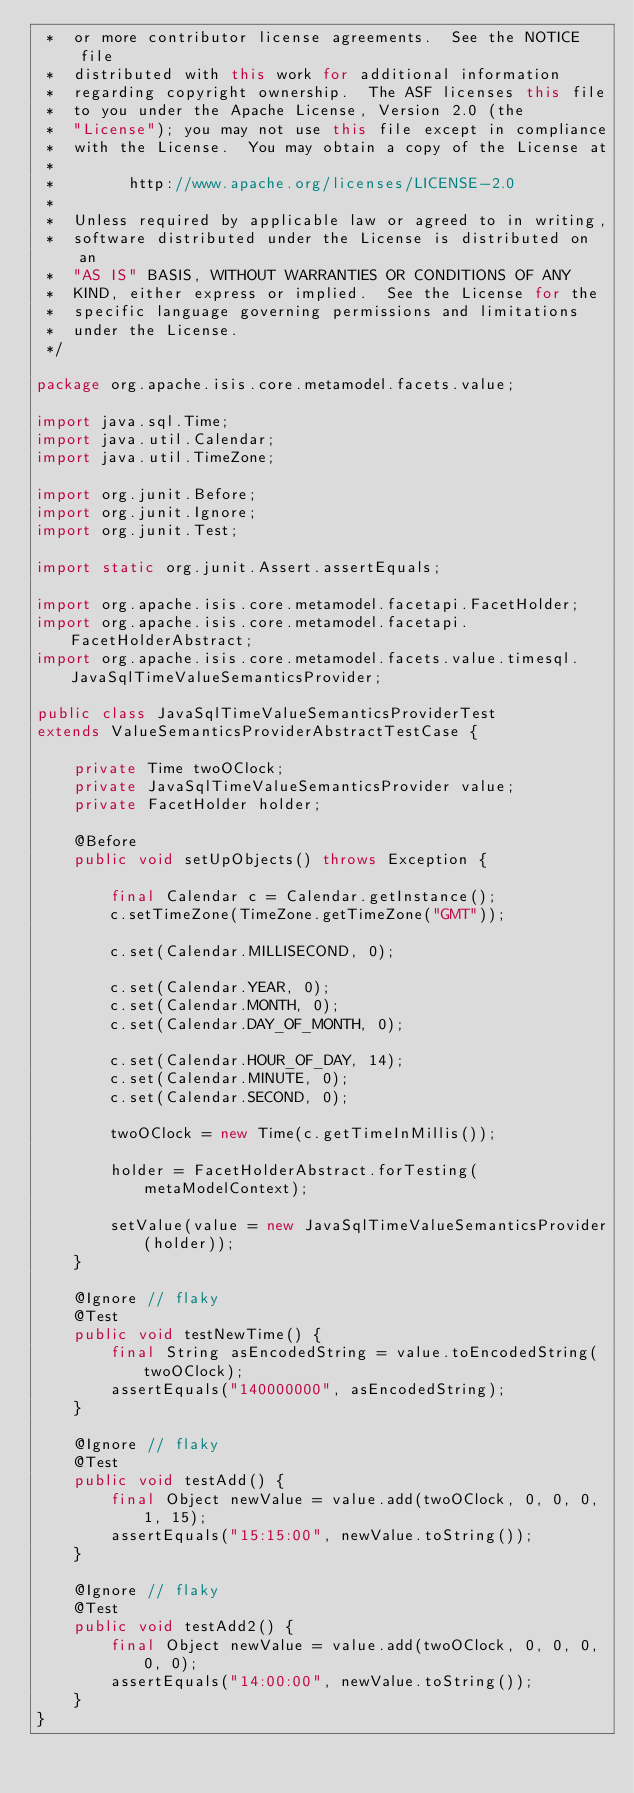<code> <loc_0><loc_0><loc_500><loc_500><_Java_> *  or more contributor license agreements.  See the NOTICE file
 *  distributed with this work for additional information
 *  regarding copyright ownership.  The ASF licenses this file
 *  to you under the Apache License, Version 2.0 (the
 *  "License"); you may not use this file except in compliance
 *  with the License.  You may obtain a copy of the License at
 *
 *        http://www.apache.org/licenses/LICENSE-2.0
 *
 *  Unless required by applicable law or agreed to in writing,
 *  software distributed under the License is distributed on an
 *  "AS IS" BASIS, WITHOUT WARRANTIES OR CONDITIONS OF ANY
 *  KIND, either express or implied.  See the License for the
 *  specific language governing permissions and limitations
 *  under the License.
 */

package org.apache.isis.core.metamodel.facets.value;

import java.sql.Time;
import java.util.Calendar;
import java.util.TimeZone;

import org.junit.Before;
import org.junit.Ignore;
import org.junit.Test;

import static org.junit.Assert.assertEquals;

import org.apache.isis.core.metamodel.facetapi.FacetHolder;
import org.apache.isis.core.metamodel.facetapi.FacetHolderAbstract;
import org.apache.isis.core.metamodel.facets.value.timesql.JavaSqlTimeValueSemanticsProvider;

public class JavaSqlTimeValueSemanticsProviderTest
extends ValueSemanticsProviderAbstractTestCase {

    private Time twoOClock;
    private JavaSqlTimeValueSemanticsProvider value;
    private FacetHolder holder;

    @Before
    public void setUpObjects() throws Exception {

        final Calendar c = Calendar.getInstance();
        c.setTimeZone(TimeZone.getTimeZone("GMT"));

        c.set(Calendar.MILLISECOND, 0);

        c.set(Calendar.YEAR, 0);
        c.set(Calendar.MONTH, 0);
        c.set(Calendar.DAY_OF_MONTH, 0);

        c.set(Calendar.HOUR_OF_DAY, 14);
        c.set(Calendar.MINUTE, 0);
        c.set(Calendar.SECOND, 0);

        twoOClock = new Time(c.getTimeInMillis());

        holder = FacetHolderAbstract.forTesting(metaModelContext);

        setValue(value = new JavaSqlTimeValueSemanticsProvider(holder));
    }

    @Ignore // flaky
    @Test
    public void testNewTime() {
        final String asEncodedString = value.toEncodedString(twoOClock);
        assertEquals("140000000", asEncodedString);
    }

    @Ignore // flaky
    @Test
    public void testAdd() {
        final Object newValue = value.add(twoOClock, 0, 0, 0, 1, 15);
        assertEquals("15:15:00", newValue.toString());
    }

    @Ignore // flaky
    @Test
    public void testAdd2() {
        final Object newValue = value.add(twoOClock, 0, 0, 0, 0, 0);
        assertEquals("14:00:00", newValue.toString());
    }
}
</code> 